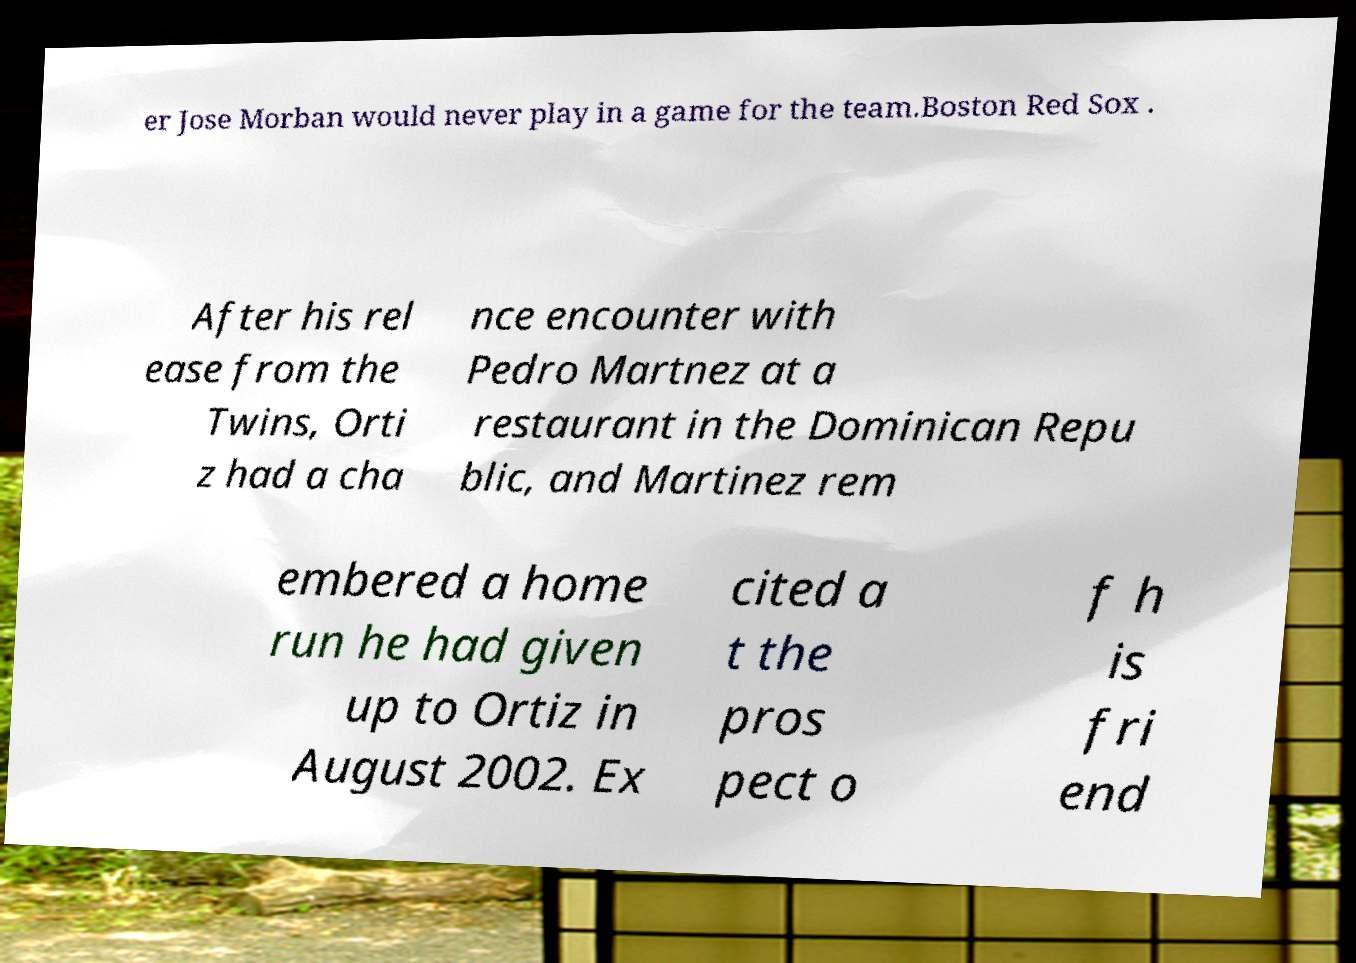Could you assist in decoding the text presented in this image and type it out clearly? er Jose Morban would never play in a game for the team.Boston Red Sox . After his rel ease from the Twins, Orti z had a cha nce encounter with Pedro Martnez at a restaurant in the Dominican Repu blic, and Martinez rem embered a home run he had given up to Ortiz in August 2002. Ex cited a t the pros pect o f h is fri end 